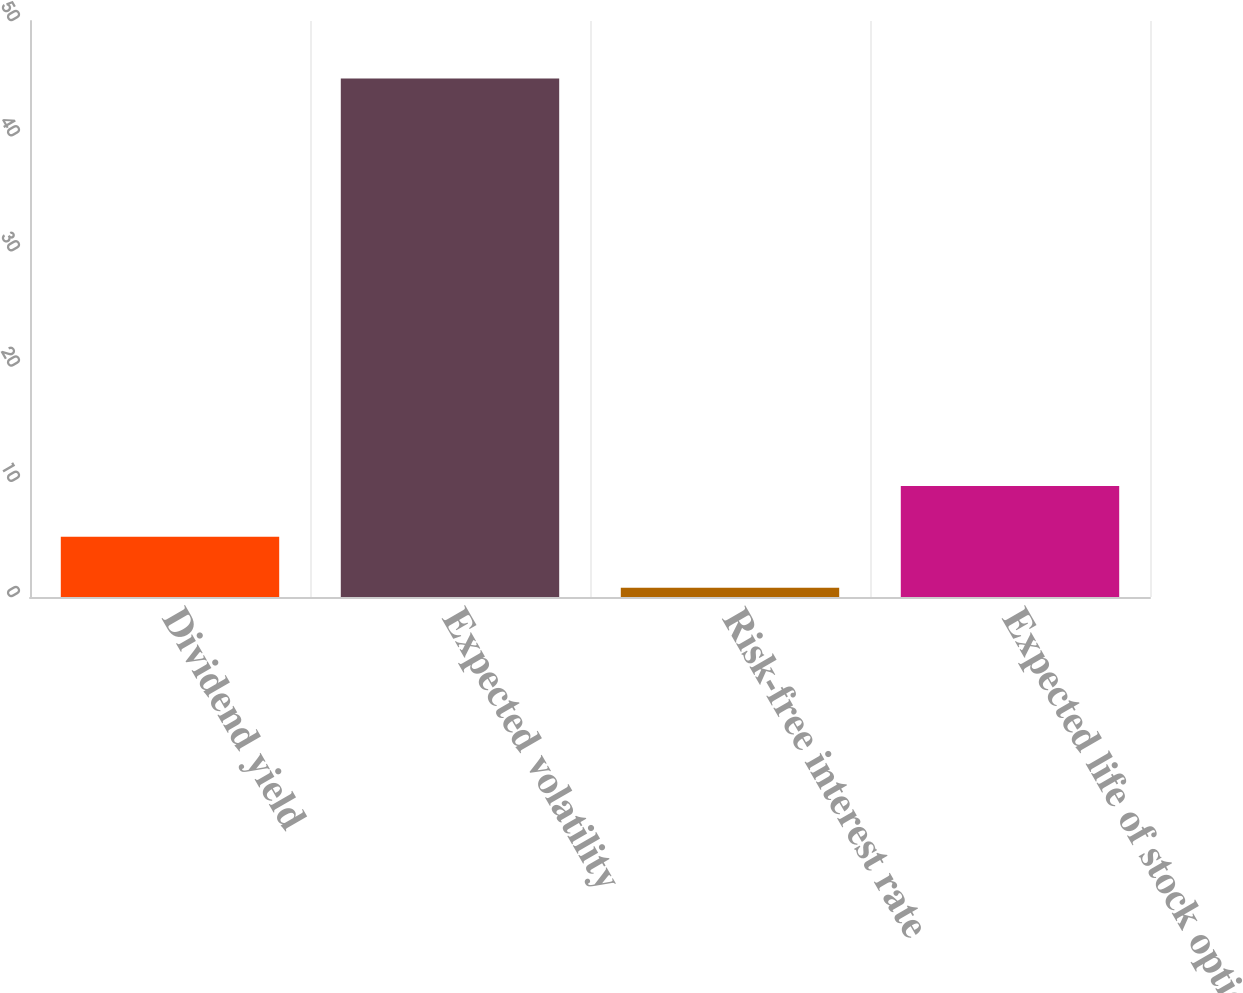<chart> <loc_0><loc_0><loc_500><loc_500><bar_chart><fcel>Dividend yield<fcel>Expected volatility<fcel>Risk-free interest rate<fcel>Expected life of stock option<nl><fcel>5.22<fcel>45<fcel>0.8<fcel>9.64<nl></chart> 